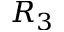<formula> <loc_0><loc_0><loc_500><loc_500>R _ { 3 }</formula> 